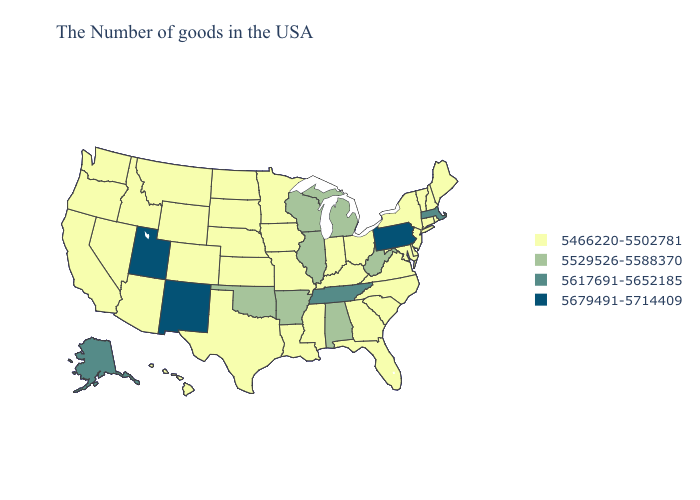What is the lowest value in the USA?
Write a very short answer. 5466220-5502781. Among the states that border Kentucky , does Indiana have the lowest value?
Short answer required. Yes. Does Kentucky have the same value as Alaska?
Give a very brief answer. No. What is the highest value in the USA?
Write a very short answer. 5679491-5714409. Which states have the lowest value in the USA?
Write a very short answer. Maine, Rhode Island, New Hampshire, Vermont, Connecticut, New York, New Jersey, Delaware, Maryland, Virginia, North Carolina, South Carolina, Ohio, Florida, Georgia, Kentucky, Indiana, Mississippi, Louisiana, Missouri, Minnesota, Iowa, Kansas, Nebraska, Texas, South Dakota, North Dakota, Wyoming, Colorado, Montana, Arizona, Idaho, Nevada, California, Washington, Oregon, Hawaii. Among the states that border Oregon , which have the highest value?
Keep it brief. Idaho, Nevada, California, Washington. Does New Jersey have the same value as Virginia?
Short answer required. Yes. What is the value of Colorado?
Be succinct. 5466220-5502781. Which states hav the highest value in the West?
Quick response, please. New Mexico, Utah. Does Illinois have the lowest value in the USA?
Answer briefly. No. Which states have the highest value in the USA?
Concise answer only. Pennsylvania, New Mexico, Utah. What is the value of North Carolina?
Be succinct. 5466220-5502781. What is the value of New Jersey?
Short answer required. 5466220-5502781. Does Arkansas have the lowest value in the USA?
Concise answer only. No. Which states hav the highest value in the MidWest?
Give a very brief answer. Michigan, Wisconsin, Illinois. 